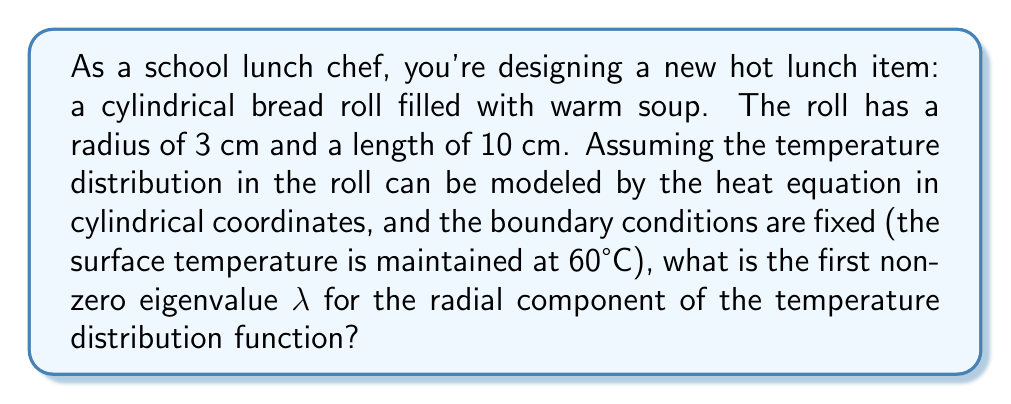Solve this math problem. Let's approach this step-by-step:

1) In cylindrical coordinates, the heat equation separates into radial and axial components. Given the fixed boundary conditions, we focus on the radial component.

2) The radial component of the heat equation in cylindrical coordinates is:

   $$\frac{1}{r}\frac{d}{dr}\left(r\frac{dR}{dr}\right) + \lambda R = 0$$

3) With fixed boundary conditions, the solution to this equation is given by Bessel functions of the first kind:

   $$R(r) = J_0(\sqrt{\lambda}r)$$

4) The boundary condition R(a) = 0 (where a is the radius) leads to:

   $$J_0(\sqrt{\lambda}a) = 0$$

5) In our case, a = 3 cm. So we need to find the smallest positive value of λ that satisfies:

   $$J_0(3\sqrt{\lambda}) = 0$$

6) The first positive zero of the Bessel function J₀(x) occurs at x ≈ 2.4048.

7) Therefore:

   $$3\sqrt{\lambda} \approx 2.4048$$

8) Solving for λ:

   $$\lambda \approx \left(\frac{2.4048}{3}\right)^2 \approx 0.6415 \text{ cm}^{-2}$$
Answer: $\lambda \approx 0.6415 \text{ cm}^{-2}$ 